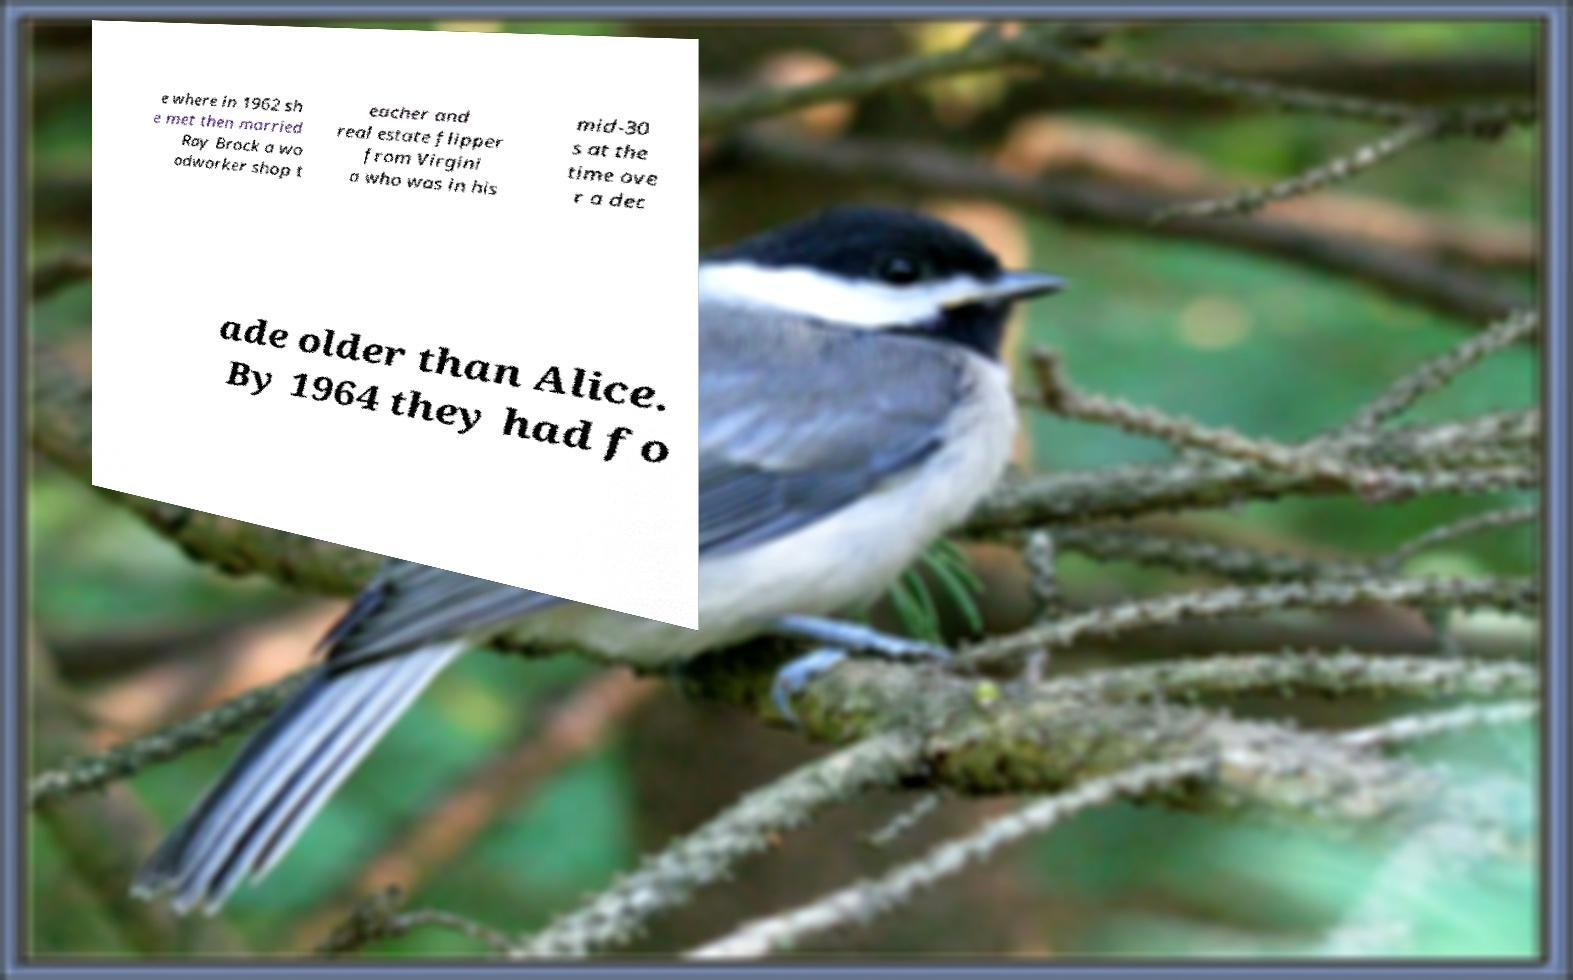Can you accurately transcribe the text from the provided image for me? e where in 1962 sh e met then married Ray Brock a wo odworker shop t eacher and real estate flipper from Virgini a who was in his mid-30 s at the time ove r a dec ade older than Alice. By 1964 they had fo 